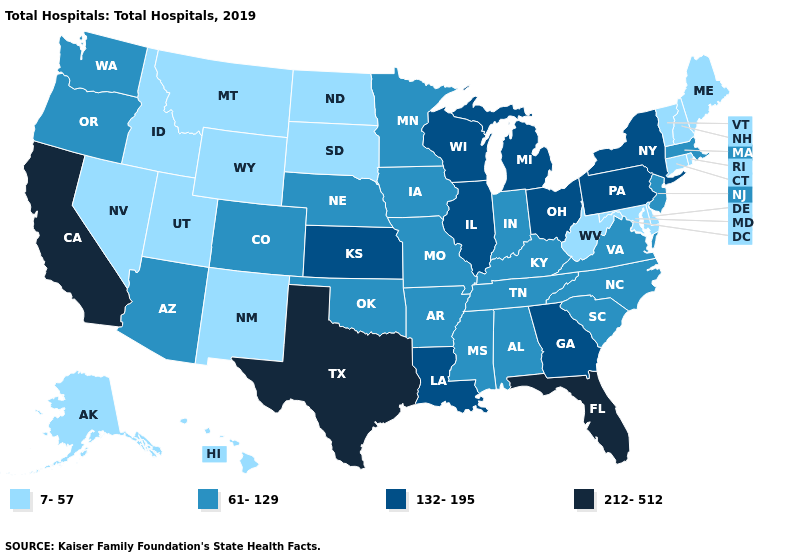Name the states that have a value in the range 7-57?
Answer briefly. Alaska, Connecticut, Delaware, Hawaii, Idaho, Maine, Maryland, Montana, Nevada, New Hampshire, New Mexico, North Dakota, Rhode Island, South Dakota, Utah, Vermont, West Virginia, Wyoming. What is the value of New York?
Concise answer only. 132-195. What is the highest value in the MidWest ?
Be succinct. 132-195. Name the states that have a value in the range 132-195?
Answer briefly. Georgia, Illinois, Kansas, Louisiana, Michigan, New York, Ohio, Pennsylvania, Wisconsin. Does Florida have the highest value in the USA?
Concise answer only. Yes. Does Texas have the highest value in the USA?
Short answer required. Yes. Name the states that have a value in the range 61-129?
Write a very short answer. Alabama, Arizona, Arkansas, Colorado, Indiana, Iowa, Kentucky, Massachusetts, Minnesota, Mississippi, Missouri, Nebraska, New Jersey, North Carolina, Oklahoma, Oregon, South Carolina, Tennessee, Virginia, Washington. What is the lowest value in states that border Kansas?
Give a very brief answer. 61-129. What is the value of Tennessee?
Give a very brief answer. 61-129. What is the lowest value in the USA?
Concise answer only. 7-57. Which states have the lowest value in the USA?
Be succinct. Alaska, Connecticut, Delaware, Hawaii, Idaho, Maine, Maryland, Montana, Nevada, New Hampshire, New Mexico, North Dakota, Rhode Island, South Dakota, Utah, Vermont, West Virginia, Wyoming. Does Texas have the highest value in the USA?
Be succinct. Yes. What is the lowest value in the MidWest?
Answer briefly. 7-57. What is the value of Florida?
Concise answer only. 212-512. Which states hav the highest value in the West?
Quick response, please. California. 